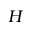<formula> <loc_0><loc_0><loc_500><loc_500>H</formula> 